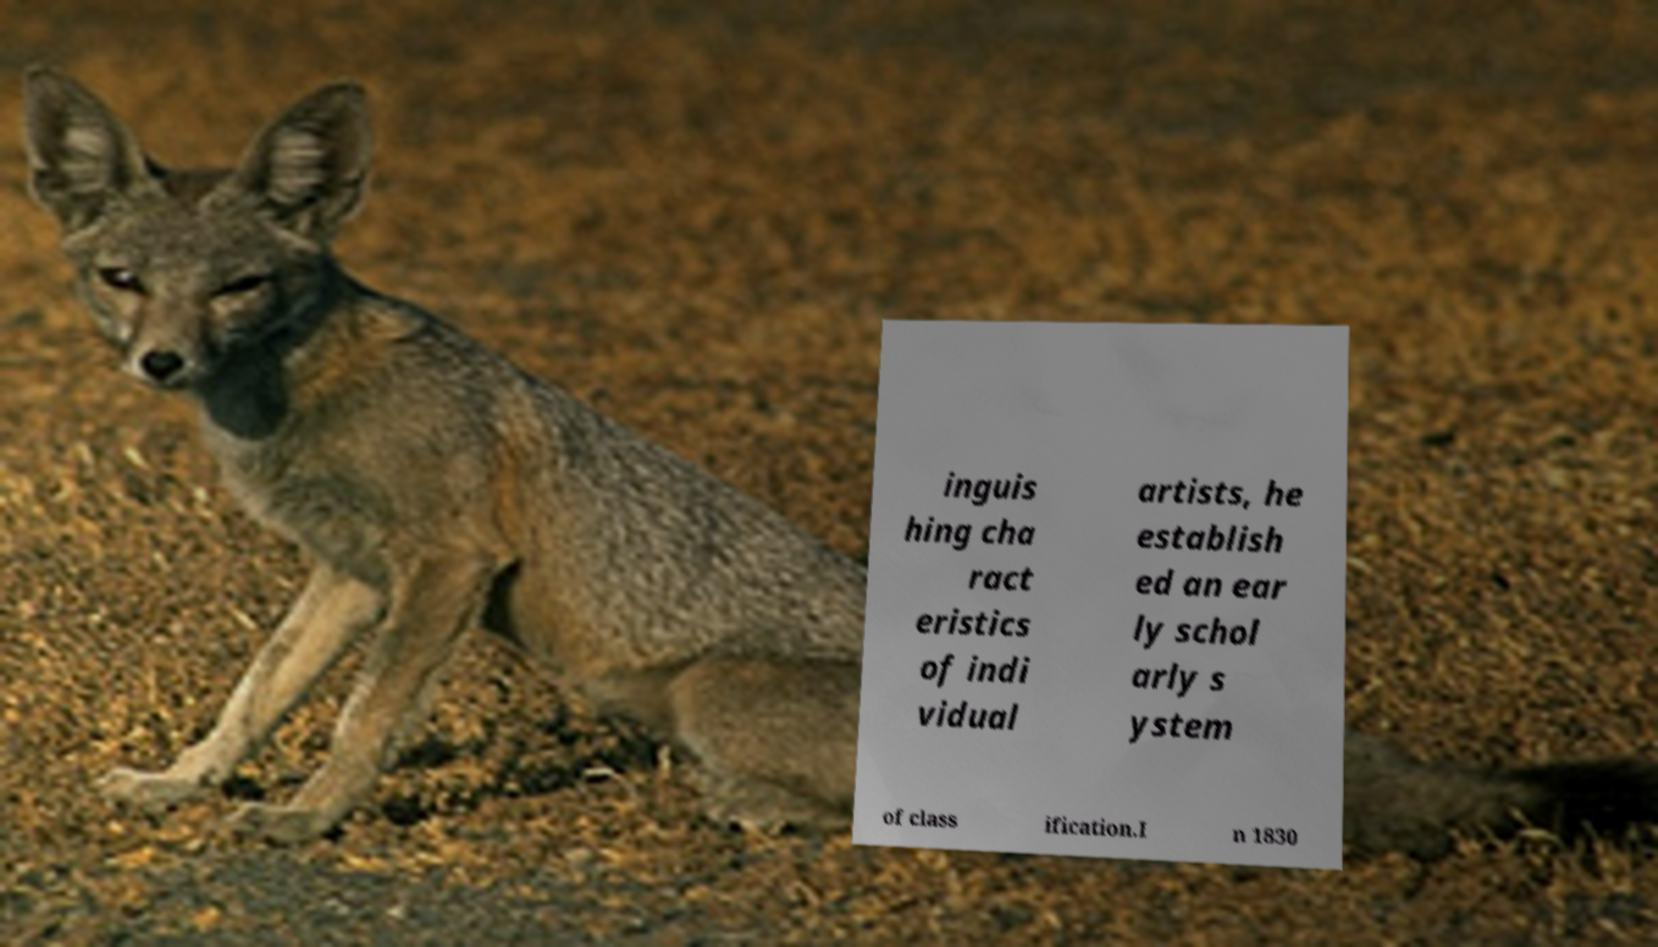I need the written content from this picture converted into text. Can you do that? inguis hing cha ract eristics of indi vidual artists, he establish ed an ear ly schol arly s ystem of class ification.I n 1830 